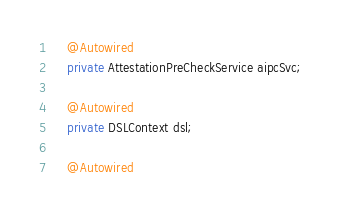<code> <loc_0><loc_0><loc_500><loc_500><_Java_>    @Autowired
    private AttestationPreCheckService aipcSvc;

    @Autowired
    private DSLContext dsl;

    @Autowired</code> 